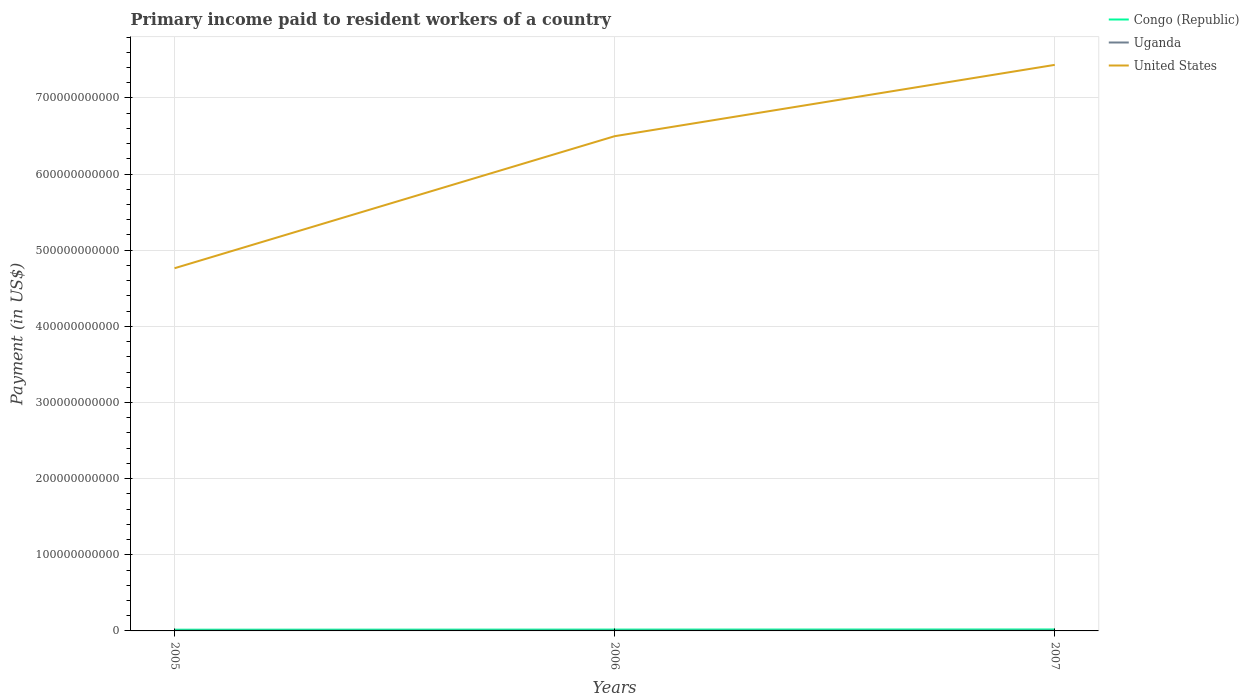Does the line corresponding to Uganda intersect with the line corresponding to United States?
Ensure brevity in your answer.  No. Is the number of lines equal to the number of legend labels?
Give a very brief answer. Yes. Across all years, what is the maximum amount paid to workers in Congo (Republic)?
Offer a terse response. 1.60e+09. What is the total amount paid to workers in Uganda in the graph?
Offer a very short reply. -4.11e+07. What is the difference between the highest and the second highest amount paid to workers in Uganda?
Offer a very short reply. 4.11e+07. What is the difference between the highest and the lowest amount paid to workers in United States?
Your answer should be very brief. 2. Is the amount paid to workers in Uganda strictly greater than the amount paid to workers in United States over the years?
Give a very brief answer. Yes. How many lines are there?
Ensure brevity in your answer.  3. What is the difference between two consecutive major ticks on the Y-axis?
Your answer should be compact. 1.00e+11. Does the graph contain any zero values?
Offer a very short reply. No. Where does the legend appear in the graph?
Provide a short and direct response. Top right. How are the legend labels stacked?
Ensure brevity in your answer.  Vertical. What is the title of the graph?
Provide a short and direct response. Primary income paid to resident workers of a country. Does "Djibouti" appear as one of the legend labels in the graph?
Your response must be concise. No. What is the label or title of the Y-axis?
Keep it short and to the point. Payment (in US$). What is the Payment (in US$) in Congo (Republic) in 2005?
Provide a short and direct response. 1.60e+09. What is the Payment (in US$) in Uganda in 2005?
Your answer should be very brief. 2.87e+08. What is the Payment (in US$) in United States in 2005?
Make the answer very short. 4.76e+11. What is the Payment (in US$) of Congo (Republic) in 2006?
Provide a succinct answer. 1.77e+09. What is the Payment (in US$) of Uganda in 2006?
Ensure brevity in your answer.  3.00e+08. What is the Payment (in US$) of United States in 2006?
Provide a succinct answer. 6.50e+11. What is the Payment (in US$) of Congo (Republic) in 2007?
Provide a succinct answer. 1.91e+09. What is the Payment (in US$) of Uganda in 2007?
Ensure brevity in your answer.  3.28e+08. What is the Payment (in US$) in United States in 2007?
Provide a short and direct response. 7.43e+11. Across all years, what is the maximum Payment (in US$) in Congo (Republic)?
Ensure brevity in your answer.  1.91e+09. Across all years, what is the maximum Payment (in US$) in Uganda?
Your response must be concise. 3.28e+08. Across all years, what is the maximum Payment (in US$) of United States?
Provide a short and direct response. 7.43e+11. Across all years, what is the minimum Payment (in US$) in Congo (Republic)?
Keep it short and to the point. 1.60e+09. Across all years, what is the minimum Payment (in US$) of Uganda?
Your response must be concise. 2.87e+08. Across all years, what is the minimum Payment (in US$) in United States?
Offer a terse response. 4.76e+11. What is the total Payment (in US$) in Congo (Republic) in the graph?
Your answer should be compact. 5.28e+09. What is the total Payment (in US$) in Uganda in the graph?
Your answer should be compact. 9.15e+08. What is the total Payment (in US$) of United States in the graph?
Your response must be concise. 1.87e+12. What is the difference between the Payment (in US$) of Congo (Republic) in 2005 and that in 2006?
Your answer should be very brief. -1.77e+08. What is the difference between the Payment (in US$) in Uganda in 2005 and that in 2006?
Provide a succinct answer. -1.35e+07. What is the difference between the Payment (in US$) in United States in 2005 and that in 2006?
Give a very brief answer. -1.73e+11. What is the difference between the Payment (in US$) in Congo (Republic) in 2005 and that in 2007?
Your answer should be compact. -3.13e+08. What is the difference between the Payment (in US$) in Uganda in 2005 and that in 2007?
Provide a succinct answer. -4.11e+07. What is the difference between the Payment (in US$) of United States in 2005 and that in 2007?
Keep it short and to the point. -2.67e+11. What is the difference between the Payment (in US$) of Congo (Republic) in 2006 and that in 2007?
Provide a succinct answer. -1.35e+08. What is the difference between the Payment (in US$) of Uganda in 2006 and that in 2007?
Your answer should be compact. -2.76e+07. What is the difference between the Payment (in US$) in United States in 2006 and that in 2007?
Make the answer very short. -9.37e+1. What is the difference between the Payment (in US$) in Congo (Republic) in 2005 and the Payment (in US$) in Uganda in 2006?
Offer a terse response. 1.30e+09. What is the difference between the Payment (in US$) in Congo (Republic) in 2005 and the Payment (in US$) in United States in 2006?
Provide a short and direct response. -6.48e+11. What is the difference between the Payment (in US$) of Uganda in 2005 and the Payment (in US$) of United States in 2006?
Your response must be concise. -6.49e+11. What is the difference between the Payment (in US$) of Congo (Republic) in 2005 and the Payment (in US$) of Uganda in 2007?
Provide a succinct answer. 1.27e+09. What is the difference between the Payment (in US$) of Congo (Republic) in 2005 and the Payment (in US$) of United States in 2007?
Give a very brief answer. -7.42e+11. What is the difference between the Payment (in US$) of Uganda in 2005 and the Payment (in US$) of United States in 2007?
Ensure brevity in your answer.  -7.43e+11. What is the difference between the Payment (in US$) of Congo (Republic) in 2006 and the Payment (in US$) of Uganda in 2007?
Keep it short and to the point. 1.44e+09. What is the difference between the Payment (in US$) in Congo (Republic) in 2006 and the Payment (in US$) in United States in 2007?
Offer a very short reply. -7.42e+11. What is the difference between the Payment (in US$) in Uganda in 2006 and the Payment (in US$) in United States in 2007?
Your response must be concise. -7.43e+11. What is the average Payment (in US$) in Congo (Republic) per year?
Offer a terse response. 1.76e+09. What is the average Payment (in US$) of Uganda per year?
Offer a terse response. 3.05e+08. What is the average Payment (in US$) in United States per year?
Keep it short and to the point. 6.23e+11. In the year 2005, what is the difference between the Payment (in US$) of Congo (Republic) and Payment (in US$) of Uganda?
Give a very brief answer. 1.31e+09. In the year 2005, what is the difference between the Payment (in US$) of Congo (Republic) and Payment (in US$) of United States?
Provide a short and direct response. -4.75e+11. In the year 2005, what is the difference between the Payment (in US$) of Uganda and Payment (in US$) of United States?
Your answer should be compact. -4.76e+11. In the year 2006, what is the difference between the Payment (in US$) in Congo (Republic) and Payment (in US$) in Uganda?
Make the answer very short. 1.47e+09. In the year 2006, what is the difference between the Payment (in US$) in Congo (Republic) and Payment (in US$) in United States?
Your answer should be compact. -6.48e+11. In the year 2006, what is the difference between the Payment (in US$) of Uganda and Payment (in US$) of United States?
Give a very brief answer. -6.49e+11. In the year 2007, what is the difference between the Payment (in US$) in Congo (Republic) and Payment (in US$) in Uganda?
Your answer should be very brief. 1.58e+09. In the year 2007, what is the difference between the Payment (in US$) in Congo (Republic) and Payment (in US$) in United States?
Your response must be concise. -7.42e+11. In the year 2007, what is the difference between the Payment (in US$) of Uganda and Payment (in US$) of United States?
Your response must be concise. -7.43e+11. What is the ratio of the Payment (in US$) in Congo (Republic) in 2005 to that in 2006?
Ensure brevity in your answer.  0.9. What is the ratio of the Payment (in US$) of Uganda in 2005 to that in 2006?
Your answer should be compact. 0.96. What is the ratio of the Payment (in US$) in United States in 2005 to that in 2006?
Provide a succinct answer. 0.73. What is the ratio of the Payment (in US$) of Congo (Republic) in 2005 to that in 2007?
Offer a very short reply. 0.84. What is the ratio of the Payment (in US$) in Uganda in 2005 to that in 2007?
Keep it short and to the point. 0.87. What is the ratio of the Payment (in US$) of United States in 2005 to that in 2007?
Offer a terse response. 0.64. What is the ratio of the Payment (in US$) in Congo (Republic) in 2006 to that in 2007?
Keep it short and to the point. 0.93. What is the ratio of the Payment (in US$) of Uganda in 2006 to that in 2007?
Your answer should be very brief. 0.92. What is the ratio of the Payment (in US$) in United States in 2006 to that in 2007?
Make the answer very short. 0.87. What is the difference between the highest and the second highest Payment (in US$) in Congo (Republic)?
Keep it short and to the point. 1.35e+08. What is the difference between the highest and the second highest Payment (in US$) of Uganda?
Keep it short and to the point. 2.76e+07. What is the difference between the highest and the second highest Payment (in US$) in United States?
Ensure brevity in your answer.  9.37e+1. What is the difference between the highest and the lowest Payment (in US$) of Congo (Republic)?
Offer a terse response. 3.13e+08. What is the difference between the highest and the lowest Payment (in US$) of Uganda?
Offer a terse response. 4.11e+07. What is the difference between the highest and the lowest Payment (in US$) in United States?
Offer a very short reply. 2.67e+11. 